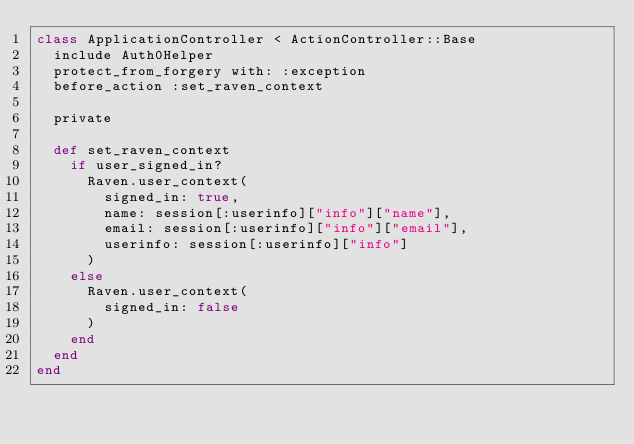Convert code to text. <code><loc_0><loc_0><loc_500><loc_500><_Ruby_>class ApplicationController < ActionController::Base
  include Auth0Helper
  protect_from_forgery with: :exception
  before_action :set_raven_context

  private

  def set_raven_context
    if user_signed_in?
      Raven.user_context(
        signed_in: true,
        name: session[:userinfo]["info"]["name"],
        email: session[:userinfo]["info"]["email"],
        userinfo: session[:userinfo]["info"]
      )
    else
      Raven.user_context(
        signed_in: false
      )
    end
  end
end
</code> 